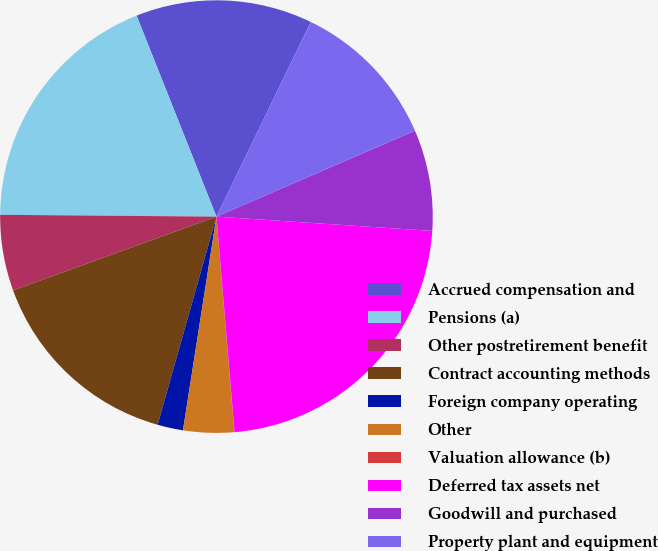Convert chart to OTSL. <chart><loc_0><loc_0><loc_500><loc_500><pie_chart><fcel>Accrued compensation and<fcel>Pensions (a)<fcel>Other postretirement benefit<fcel>Contract accounting methods<fcel>Foreign company operating<fcel>Other<fcel>Valuation allowance (b)<fcel>Deferred tax assets net<fcel>Goodwill and purchased<fcel>Property plant and equipment<nl><fcel>13.2%<fcel>18.85%<fcel>5.67%<fcel>15.08%<fcel>1.91%<fcel>3.79%<fcel>0.02%<fcel>22.61%<fcel>7.55%<fcel>11.32%<nl></chart> 